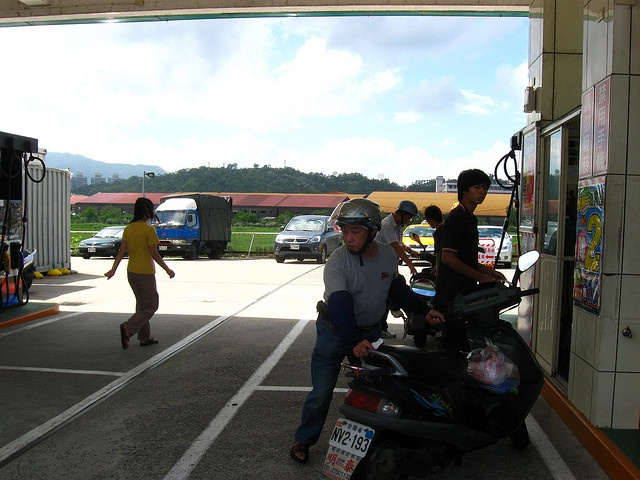Describe the objects in this image and their specific colors. I can see motorcycle in gray, black, maroon, and white tones, people in gray, black, and maroon tones, people in gray, black, maroon, and olive tones, truck in gray, black, white, and darkgray tones, and people in gray, black, olive, and maroon tones in this image. 